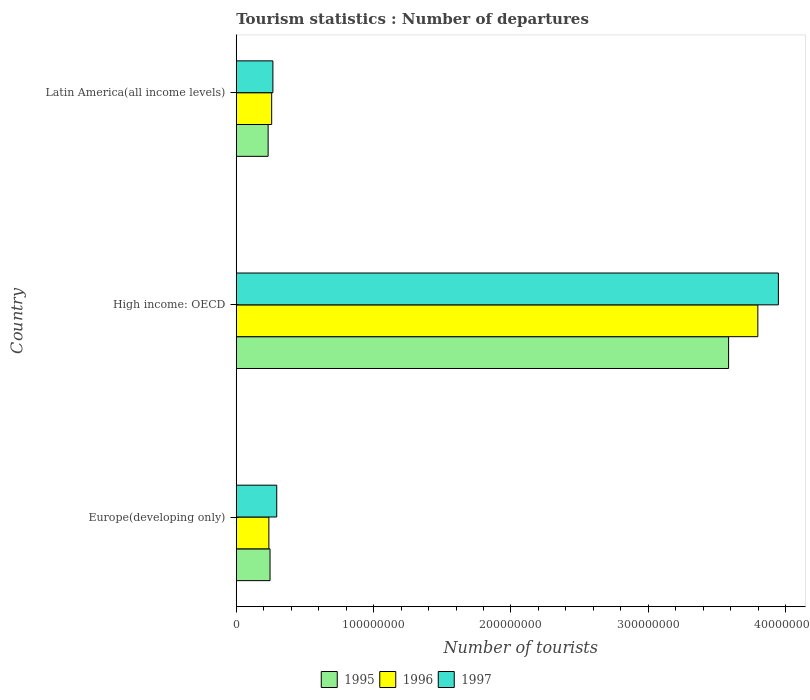How many different coloured bars are there?
Your answer should be compact. 3. How many groups of bars are there?
Make the answer very short. 3. How many bars are there on the 3rd tick from the bottom?
Ensure brevity in your answer.  3. What is the label of the 2nd group of bars from the top?
Offer a very short reply. High income: OECD. In how many cases, is the number of bars for a given country not equal to the number of legend labels?
Offer a very short reply. 0. What is the number of tourist departures in 1997 in Latin America(all income levels)?
Your response must be concise. 2.67e+07. Across all countries, what is the maximum number of tourist departures in 1997?
Offer a very short reply. 3.95e+08. Across all countries, what is the minimum number of tourist departures in 1997?
Your response must be concise. 2.67e+07. In which country was the number of tourist departures in 1995 maximum?
Ensure brevity in your answer.  High income: OECD. In which country was the number of tourist departures in 1996 minimum?
Provide a short and direct response. Europe(developing only). What is the total number of tourist departures in 1995 in the graph?
Provide a short and direct response. 4.06e+08. What is the difference between the number of tourist departures in 1995 in Europe(developing only) and that in High income: OECD?
Make the answer very short. -3.34e+08. What is the difference between the number of tourist departures in 1997 in High income: OECD and the number of tourist departures in 1995 in Europe(developing only)?
Your answer should be very brief. 3.70e+08. What is the average number of tourist departures in 1995 per country?
Offer a very short reply. 1.35e+08. What is the difference between the number of tourist departures in 1996 and number of tourist departures in 1997 in Europe(developing only)?
Offer a terse response. -5.72e+06. What is the ratio of the number of tourist departures in 1997 in Europe(developing only) to that in High income: OECD?
Your answer should be compact. 0.07. Is the number of tourist departures in 1995 in Europe(developing only) less than that in High income: OECD?
Provide a succinct answer. Yes. Is the difference between the number of tourist departures in 1996 in Europe(developing only) and Latin America(all income levels) greater than the difference between the number of tourist departures in 1997 in Europe(developing only) and Latin America(all income levels)?
Provide a short and direct response. No. What is the difference between the highest and the second highest number of tourist departures in 1995?
Ensure brevity in your answer.  3.34e+08. What is the difference between the highest and the lowest number of tourist departures in 1996?
Offer a terse response. 3.56e+08. Is the sum of the number of tourist departures in 1996 in Europe(developing only) and High income: OECD greater than the maximum number of tourist departures in 1997 across all countries?
Offer a terse response. Yes. What does the 3rd bar from the bottom in Europe(developing only) represents?
Your answer should be very brief. 1997. How many countries are there in the graph?
Your answer should be compact. 3. Does the graph contain grids?
Keep it short and to the point. No. How many legend labels are there?
Make the answer very short. 3. What is the title of the graph?
Ensure brevity in your answer.  Tourism statistics : Number of departures. What is the label or title of the X-axis?
Offer a very short reply. Number of tourists. What is the label or title of the Y-axis?
Provide a succinct answer. Country. What is the Number of tourists in 1995 in Europe(developing only)?
Give a very brief answer. 2.46e+07. What is the Number of tourists in 1996 in Europe(developing only)?
Offer a very short reply. 2.38e+07. What is the Number of tourists of 1997 in Europe(developing only)?
Keep it short and to the point. 2.95e+07. What is the Number of tourists in 1995 in High income: OECD?
Give a very brief answer. 3.58e+08. What is the Number of tourists of 1996 in High income: OECD?
Give a very brief answer. 3.80e+08. What is the Number of tourists of 1997 in High income: OECD?
Your answer should be compact. 3.95e+08. What is the Number of tourists of 1995 in Latin America(all income levels)?
Your answer should be very brief. 2.32e+07. What is the Number of tourists of 1996 in Latin America(all income levels)?
Provide a short and direct response. 2.58e+07. What is the Number of tourists in 1997 in Latin America(all income levels)?
Make the answer very short. 2.67e+07. Across all countries, what is the maximum Number of tourists in 1995?
Provide a short and direct response. 3.58e+08. Across all countries, what is the maximum Number of tourists of 1996?
Offer a terse response. 3.80e+08. Across all countries, what is the maximum Number of tourists in 1997?
Offer a very short reply. 3.95e+08. Across all countries, what is the minimum Number of tourists in 1995?
Keep it short and to the point. 2.32e+07. Across all countries, what is the minimum Number of tourists in 1996?
Provide a short and direct response. 2.38e+07. Across all countries, what is the minimum Number of tourists in 1997?
Your response must be concise. 2.67e+07. What is the total Number of tourists in 1995 in the graph?
Provide a succinct answer. 4.06e+08. What is the total Number of tourists in 1996 in the graph?
Offer a very short reply. 4.29e+08. What is the total Number of tourists in 1997 in the graph?
Offer a terse response. 4.51e+08. What is the difference between the Number of tourists of 1995 in Europe(developing only) and that in High income: OECD?
Offer a terse response. -3.34e+08. What is the difference between the Number of tourists in 1996 in Europe(developing only) and that in High income: OECD?
Your answer should be compact. -3.56e+08. What is the difference between the Number of tourists in 1997 in Europe(developing only) and that in High income: OECD?
Give a very brief answer. -3.65e+08. What is the difference between the Number of tourists in 1995 in Europe(developing only) and that in Latin America(all income levels)?
Make the answer very short. 1.39e+06. What is the difference between the Number of tourists in 1996 in Europe(developing only) and that in Latin America(all income levels)?
Keep it short and to the point. -2.03e+06. What is the difference between the Number of tourists in 1997 in Europe(developing only) and that in Latin America(all income levels)?
Offer a very short reply. 2.80e+06. What is the difference between the Number of tourists in 1995 in High income: OECD and that in Latin America(all income levels)?
Offer a terse response. 3.35e+08. What is the difference between the Number of tourists of 1996 in High income: OECD and that in Latin America(all income levels)?
Give a very brief answer. 3.54e+08. What is the difference between the Number of tourists in 1997 in High income: OECD and that in Latin America(all income levels)?
Offer a terse response. 3.68e+08. What is the difference between the Number of tourists in 1995 in Europe(developing only) and the Number of tourists in 1996 in High income: OECD?
Make the answer very short. -3.55e+08. What is the difference between the Number of tourists of 1995 in Europe(developing only) and the Number of tourists of 1997 in High income: OECD?
Keep it short and to the point. -3.70e+08. What is the difference between the Number of tourists of 1996 in Europe(developing only) and the Number of tourists of 1997 in High income: OECD?
Ensure brevity in your answer.  -3.71e+08. What is the difference between the Number of tourists of 1995 in Europe(developing only) and the Number of tourists of 1996 in Latin America(all income levels)?
Provide a short and direct response. -1.18e+06. What is the difference between the Number of tourists in 1995 in Europe(developing only) and the Number of tourists in 1997 in Latin America(all income levels)?
Your response must be concise. -2.07e+06. What is the difference between the Number of tourists of 1996 in Europe(developing only) and the Number of tourists of 1997 in Latin America(all income levels)?
Make the answer very short. -2.92e+06. What is the difference between the Number of tourists of 1995 in High income: OECD and the Number of tourists of 1996 in Latin America(all income levels)?
Provide a short and direct response. 3.33e+08. What is the difference between the Number of tourists in 1995 in High income: OECD and the Number of tourists in 1997 in Latin America(all income levels)?
Your answer should be very brief. 3.32e+08. What is the difference between the Number of tourists in 1996 in High income: OECD and the Number of tourists in 1997 in Latin America(all income levels)?
Ensure brevity in your answer.  3.53e+08. What is the average Number of tourists of 1995 per country?
Your response must be concise. 1.35e+08. What is the average Number of tourists in 1996 per country?
Offer a terse response. 1.43e+08. What is the average Number of tourists of 1997 per country?
Offer a terse response. 1.50e+08. What is the difference between the Number of tourists in 1995 and Number of tourists in 1996 in Europe(developing only)?
Make the answer very short. 8.44e+05. What is the difference between the Number of tourists of 1995 and Number of tourists of 1997 in Europe(developing only)?
Make the answer very short. -4.88e+06. What is the difference between the Number of tourists in 1996 and Number of tourists in 1997 in Europe(developing only)?
Offer a very short reply. -5.72e+06. What is the difference between the Number of tourists in 1995 and Number of tourists in 1996 in High income: OECD?
Provide a short and direct response. -2.13e+07. What is the difference between the Number of tourists in 1995 and Number of tourists in 1997 in High income: OECD?
Offer a very short reply. -3.63e+07. What is the difference between the Number of tourists of 1996 and Number of tourists of 1997 in High income: OECD?
Keep it short and to the point. -1.50e+07. What is the difference between the Number of tourists in 1995 and Number of tourists in 1996 in Latin America(all income levels)?
Ensure brevity in your answer.  -2.58e+06. What is the difference between the Number of tourists of 1995 and Number of tourists of 1997 in Latin America(all income levels)?
Your response must be concise. -3.47e+06. What is the difference between the Number of tourists in 1996 and Number of tourists in 1997 in Latin America(all income levels)?
Give a very brief answer. -8.90e+05. What is the ratio of the Number of tourists in 1995 in Europe(developing only) to that in High income: OECD?
Provide a succinct answer. 0.07. What is the ratio of the Number of tourists in 1996 in Europe(developing only) to that in High income: OECD?
Provide a succinct answer. 0.06. What is the ratio of the Number of tourists in 1997 in Europe(developing only) to that in High income: OECD?
Offer a very short reply. 0.07. What is the ratio of the Number of tourists in 1995 in Europe(developing only) to that in Latin America(all income levels)?
Make the answer very short. 1.06. What is the ratio of the Number of tourists in 1996 in Europe(developing only) to that in Latin America(all income levels)?
Keep it short and to the point. 0.92. What is the ratio of the Number of tourists in 1997 in Europe(developing only) to that in Latin America(all income levels)?
Ensure brevity in your answer.  1.1. What is the ratio of the Number of tourists in 1995 in High income: OECD to that in Latin America(all income levels)?
Provide a short and direct response. 15.45. What is the ratio of the Number of tourists of 1996 in High income: OECD to that in Latin America(all income levels)?
Your answer should be very brief. 14.73. What is the ratio of the Number of tourists of 1997 in High income: OECD to that in Latin America(all income levels)?
Your response must be concise. 14.8. What is the difference between the highest and the second highest Number of tourists of 1995?
Your answer should be compact. 3.34e+08. What is the difference between the highest and the second highest Number of tourists of 1996?
Make the answer very short. 3.54e+08. What is the difference between the highest and the second highest Number of tourists in 1997?
Your response must be concise. 3.65e+08. What is the difference between the highest and the lowest Number of tourists in 1995?
Your response must be concise. 3.35e+08. What is the difference between the highest and the lowest Number of tourists of 1996?
Make the answer very short. 3.56e+08. What is the difference between the highest and the lowest Number of tourists of 1997?
Offer a very short reply. 3.68e+08. 